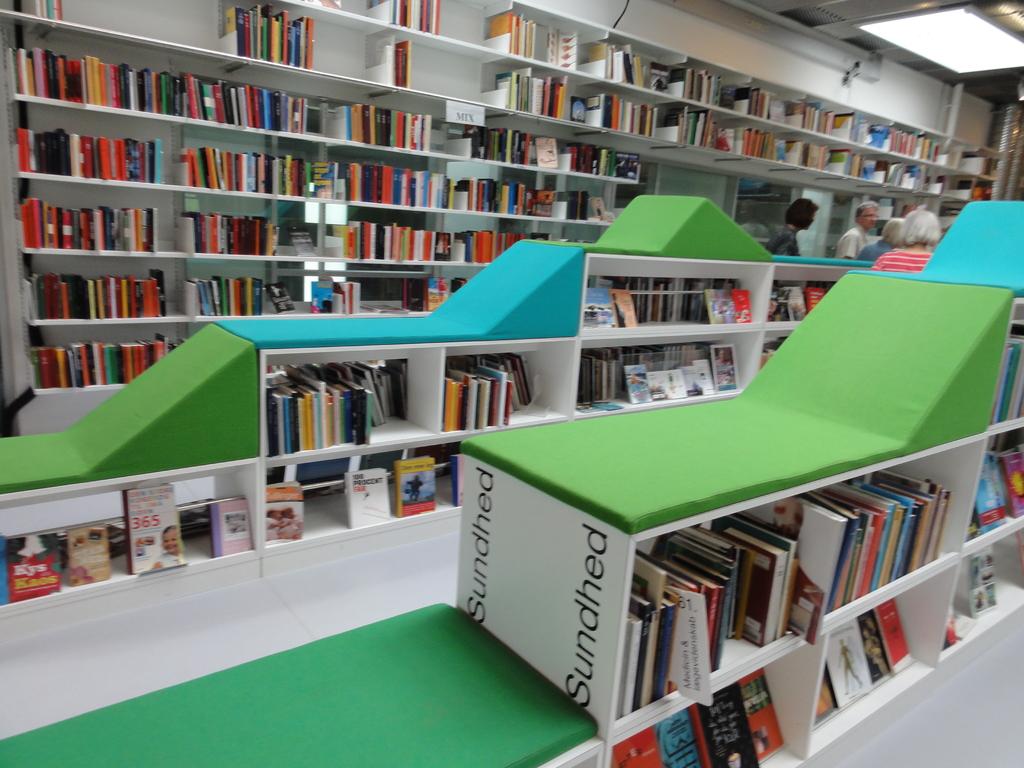What is written on the white sign?
Provide a short and direct response. Sundhed. 